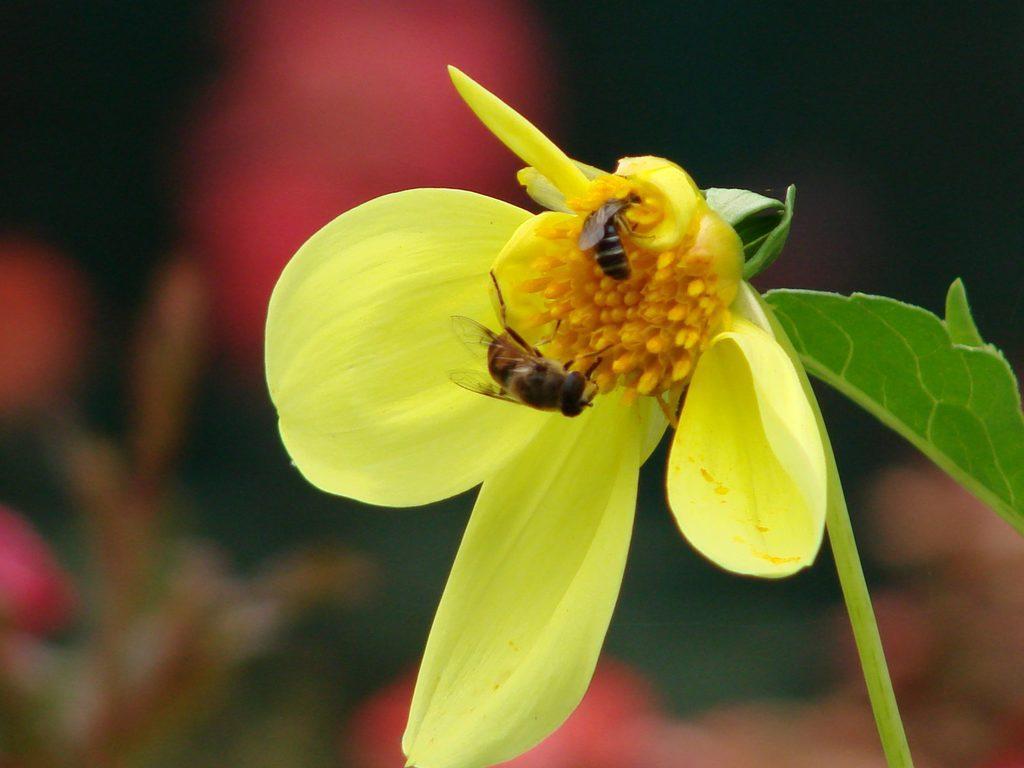Describe this image in one or two sentences. In this picture we can see honey bees on the flower. 